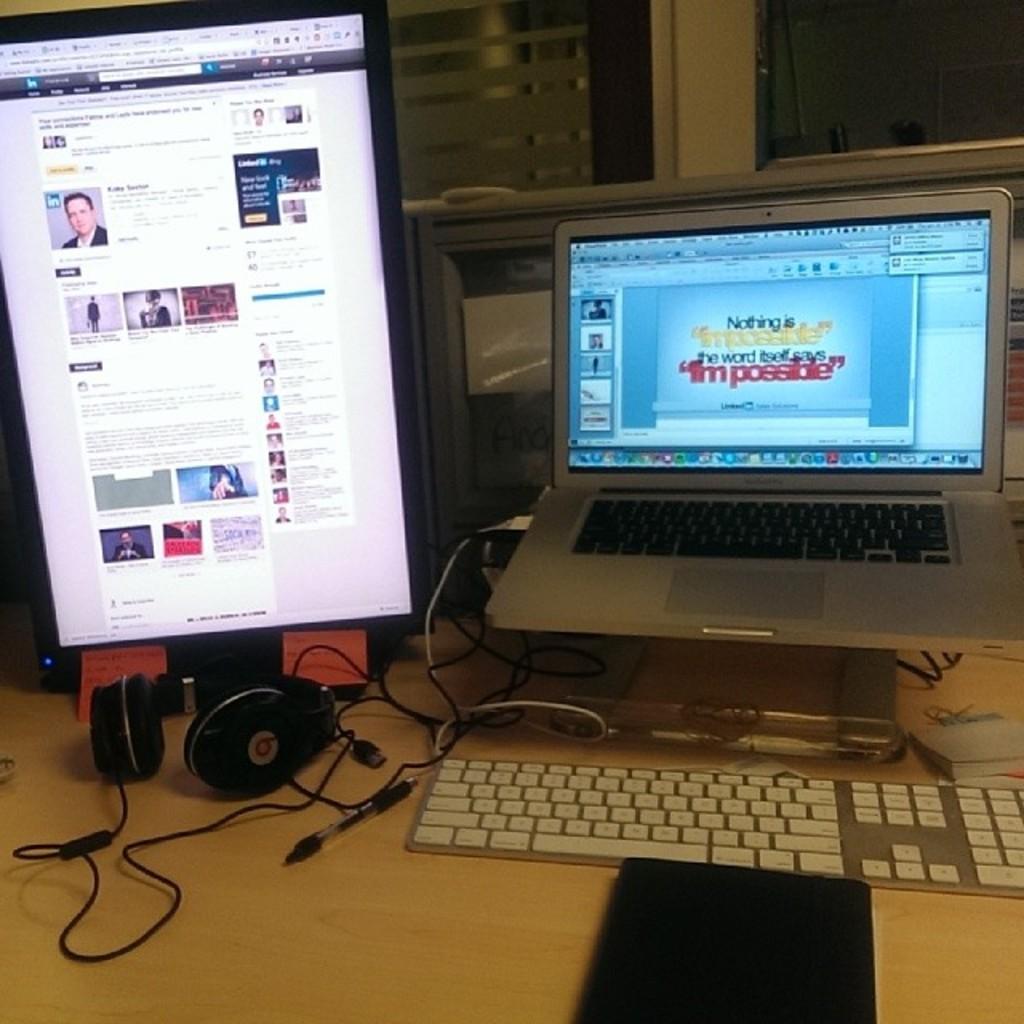What is the brand of the headphone?
Your answer should be very brief. Beats. What word is written in red on the computer screen?
Provide a succinct answer. Impossible. 